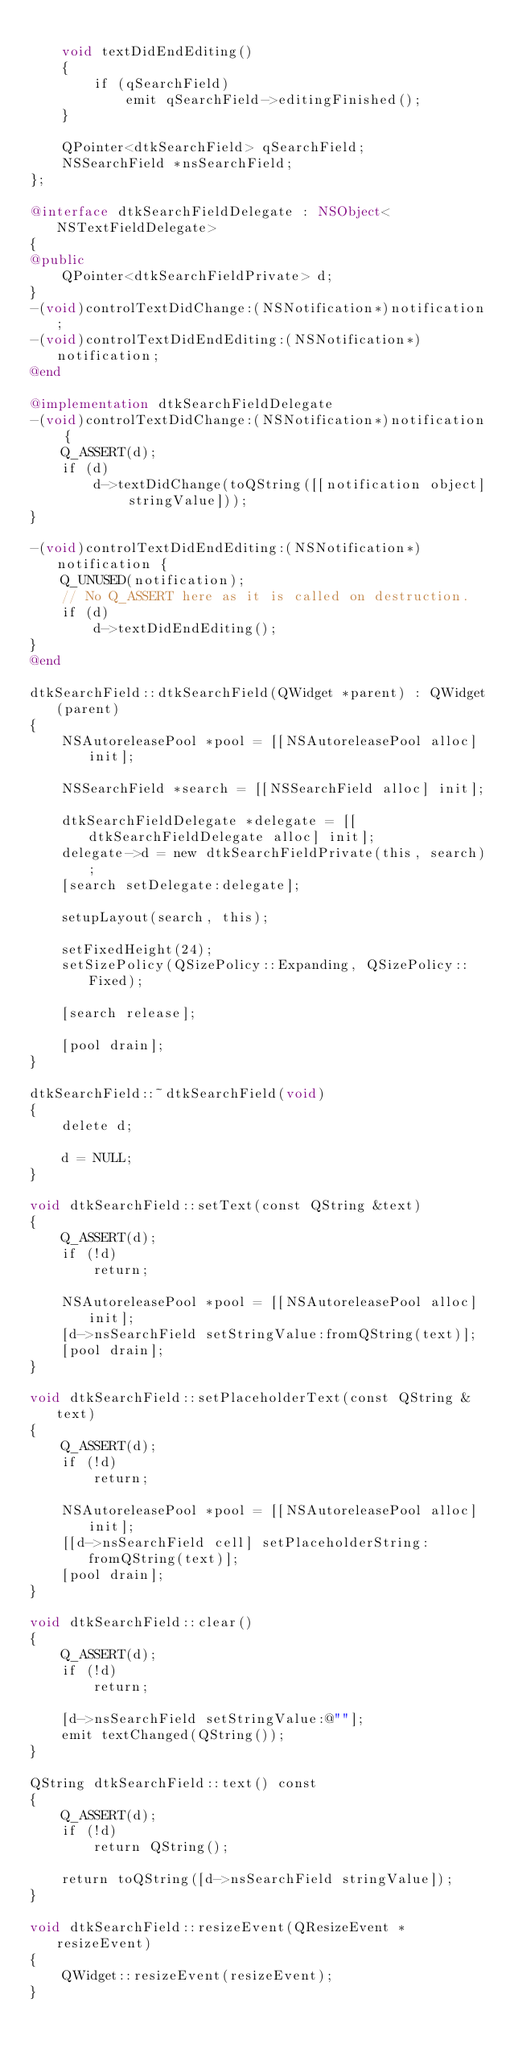<code> <loc_0><loc_0><loc_500><loc_500><_ObjectiveC_>
    void textDidEndEditing()
    {
        if (qSearchField)
            emit qSearchField->editingFinished();
    }

    QPointer<dtkSearchField> qSearchField;
    NSSearchField *nsSearchField;
};

@interface dtkSearchFieldDelegate : NSObject<NSTextFieldDelegate>
{
@public
    QPointer<dtkSearchFieldPrivate> d;
}
-(void)controlTextDidChange:(NSNotification*)notification;
-(void)controlTextDidEndEditing:(NSNotification*)notification;
@end

@implementation dtkSearchFieldDelegate
-(void)controlTextDidChange:(NSNotification*)notification {
    Q_ASSERT(d);
    if (d)
        d->textDidChange(toQString([[notification object] stringValue]));
}

-(void)controlTextDidEndEditing:(NSNotification*)notification {
    Q_UNUSED(notification);
    // No Q_ASSERT here as it is called on destruction.
    if (d)
        d->textDidEndEditing();
}
@end

dtkSearchField::dtkSearchField(QWidget *parent) : QWidget(parent)
{
    NSAutoreleasePool *pool = [[NSAutoreleasePool alloc] init];

    NSSearchField *search = [[NSSearchField alloc] init];

    dtkSearchFieldDelegate *delegate = [[dtkSearchFieldDelegate alloc] init];
    delegate->d = new dtkSearchFieldPrivate(this, search);
    [search setDelegate:delegate];

    setupLayout(search, this);

    setFixedHeight(24);
    setSizePolicy(QSizePolicy::Expanding, QSizePolicy::Fixed);

    [search release];

    [pool drain];
}

dtkSearchField::~dtkSearchField(void)
{
    delete d;

    d = NULL;
}

void dtkSearchField::setText(const QString &text)
{
    Q_ASSERT(d);
    if (!d)
        return;

    NSAutoreleasePool *pool = [[NSAutoreleasePool alloc] init];
    [d->nsSearchField setStringValue:fromQString(text)];
    [pool drain];
}

void dtkSearchField::setPlaceholderText(const QString &text)
{
    Q_ASSERT(d);
    if (!d)
        return;

    NSAutoreleasePool *pool = [[NSAutoreleasePool alloc] init];
    [[d->nsSearchField cell] setPlaceholderString:fromQString(text)];
    [pool drain];
}

void dtkSearchField::clear()
{
    Q_ASSERT(d);
    if (!d)
        return;

    [d->nsSearchField setStringValue:@""];
    emit textChanged(QString());
}

QString dtkSearchField::text() const
{
    Q_ASSERT(d);
    if (!d)
        return QString();

    return toQString([d->nsSearchField stringValue]);
}

void dtkSearchField::resizeEvent(QResizeEvent *resizeEvent)
{
    QWidget::resizeEvent(resizeEvent);
}
</code> 